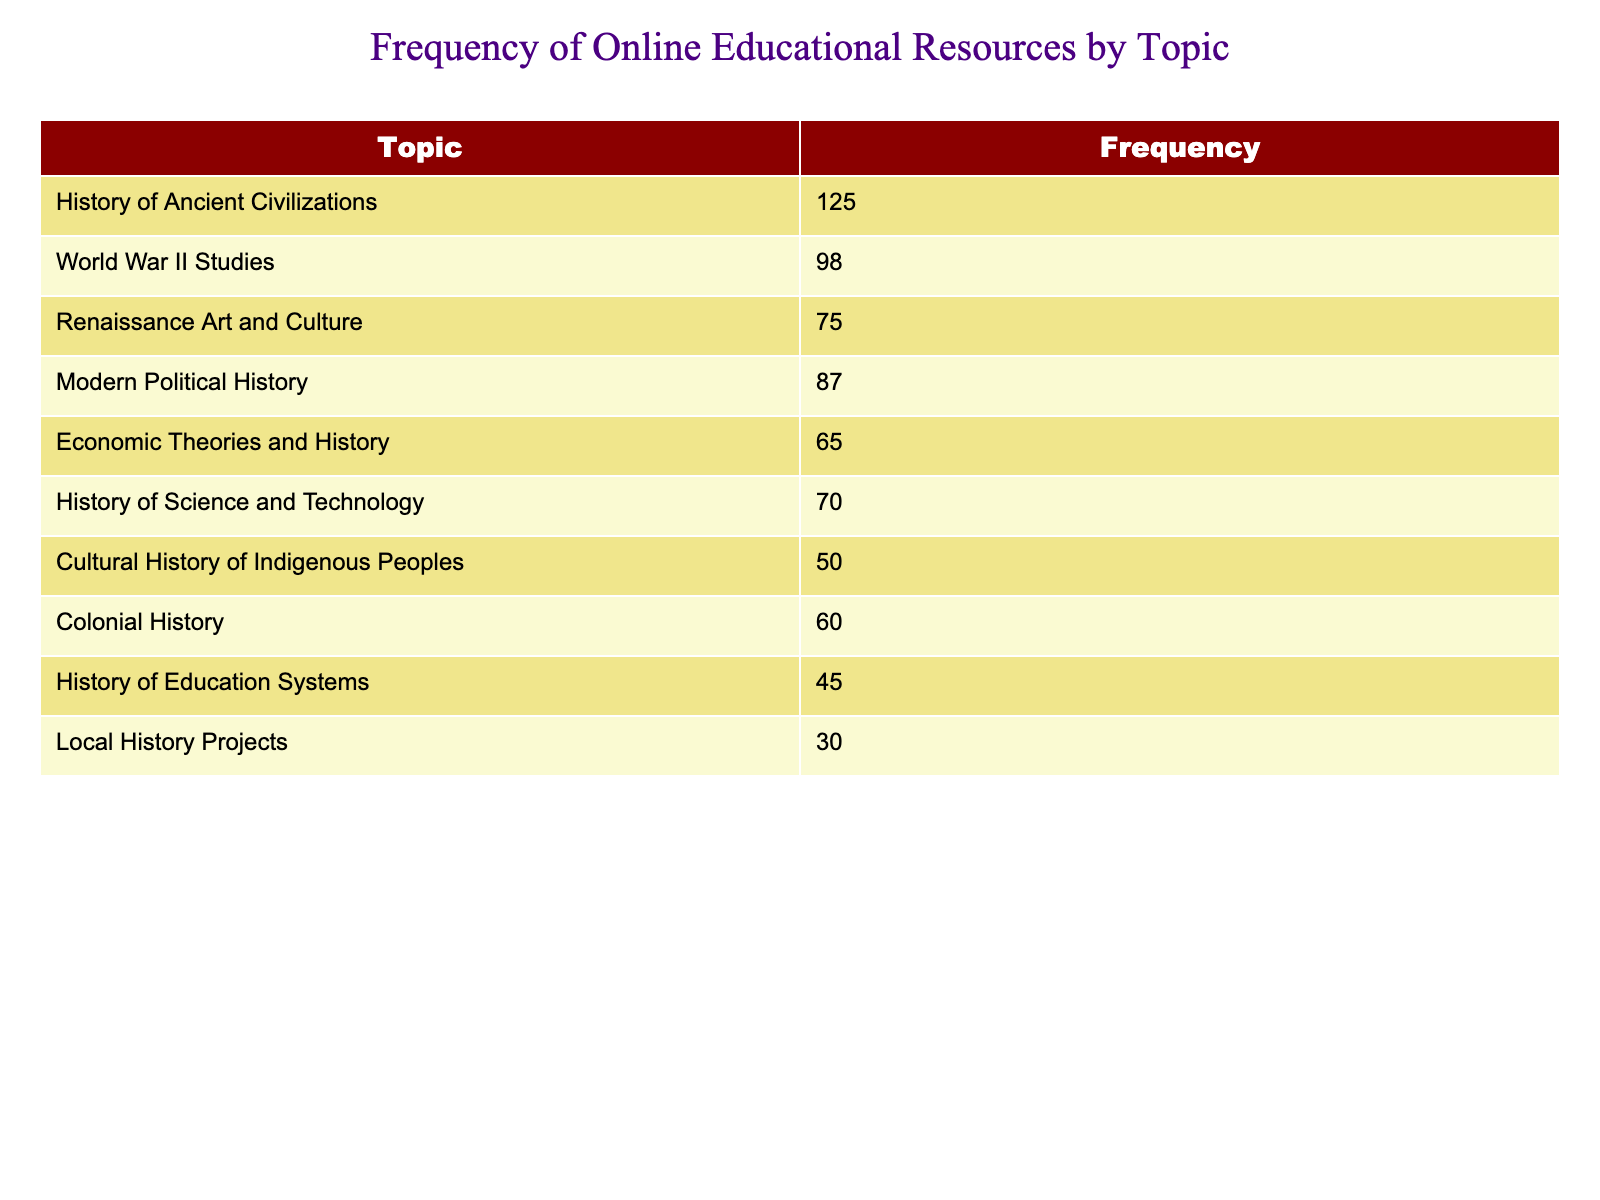What is the topic with the highest frequency of resources? The table shows various topics along with their respective frequencies. By comparing the frequencies, "History of Ancient Civilizations" has the highest frequency at 125.
Answer: History of Ancient Civilizations What is the frequency of resources for Modern Political History? The table lists the frequency for "Modern Political History" as 87. This information is taken directly from the relevant row of the table.
Answer: 87 How many resources focus on economic theories and history combined with history of science and technology? The frequency of "Economic Theories and History" is 65, and for "History of Science and Technology," it is 70. Adding these two gives 65 + 70 = 135.
Answer: 135 Is the frequency of resources on Colonial History greater than that of Cultural History of Indigenous Peoples? The frequency for "Colonial History" is 60, whereas "Cultural History of Indigenous Peoples" has 50. Since 60 is greater than 50, the statement is true.
Answer: Yes What is the average frequency of resources among all topics listed? First, we need to sum the frequencies: 125 + 98 + 75 + 87 + 65 + 70 + 50 + 60 + 45 + 30 =  795. There are 10 topics, so we divide the total frequency by the number of topics: 795/10 = 79.5.
Answer: 79.5 Which topic has resources less than 60? According to the table, "Cultural History of Indigenous Peoples" has 50, and "History of Education Systems" has 45, both are less than 60.
Answer: Cultural History of Indigenous Peoples; History of Education Systems What is the difference in frequency between the topic with the highest and lowest resources? The topic with the highest frequency is "History of Ancient Civilizations" at 125, and the lowest is "Local History Projects" at 30. The difference is 125 - 30 = 95.
Answer: 95 How many topics have a frequency greater than 70? By reviewing the table, we find that "History of Ancient Civilizations," "World War II Studies," "Modern Political History," and "History of Science and Technology" each have frequencies greater than 70, making a total of 4 topics.
Answer: 4 